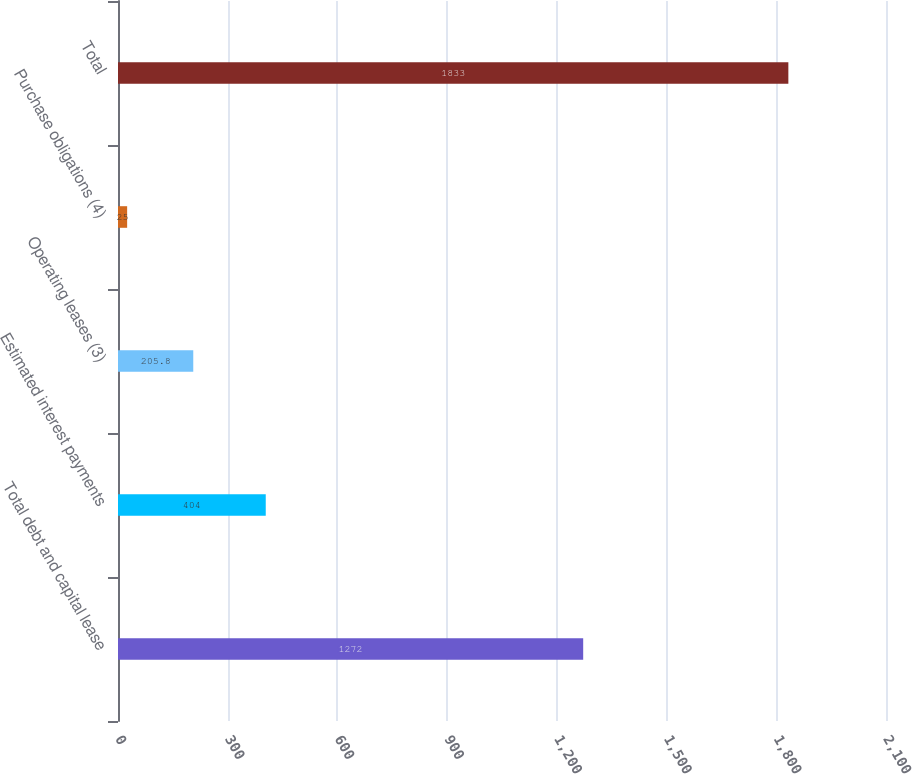Convert chart to OTSL. <chart><loc_0><loc_0><loc_500><loc_500><bar_chart><fcel>Total debt and capital lease<fcel>Estimated interest payments<fcel>Operating leases (3)<fcel>Purchase obligations (4)<fcel>Total<nl><fcel>1272<fcel>404<fcel>205.8<fcel>25<fcel>1833<nl></chart> 